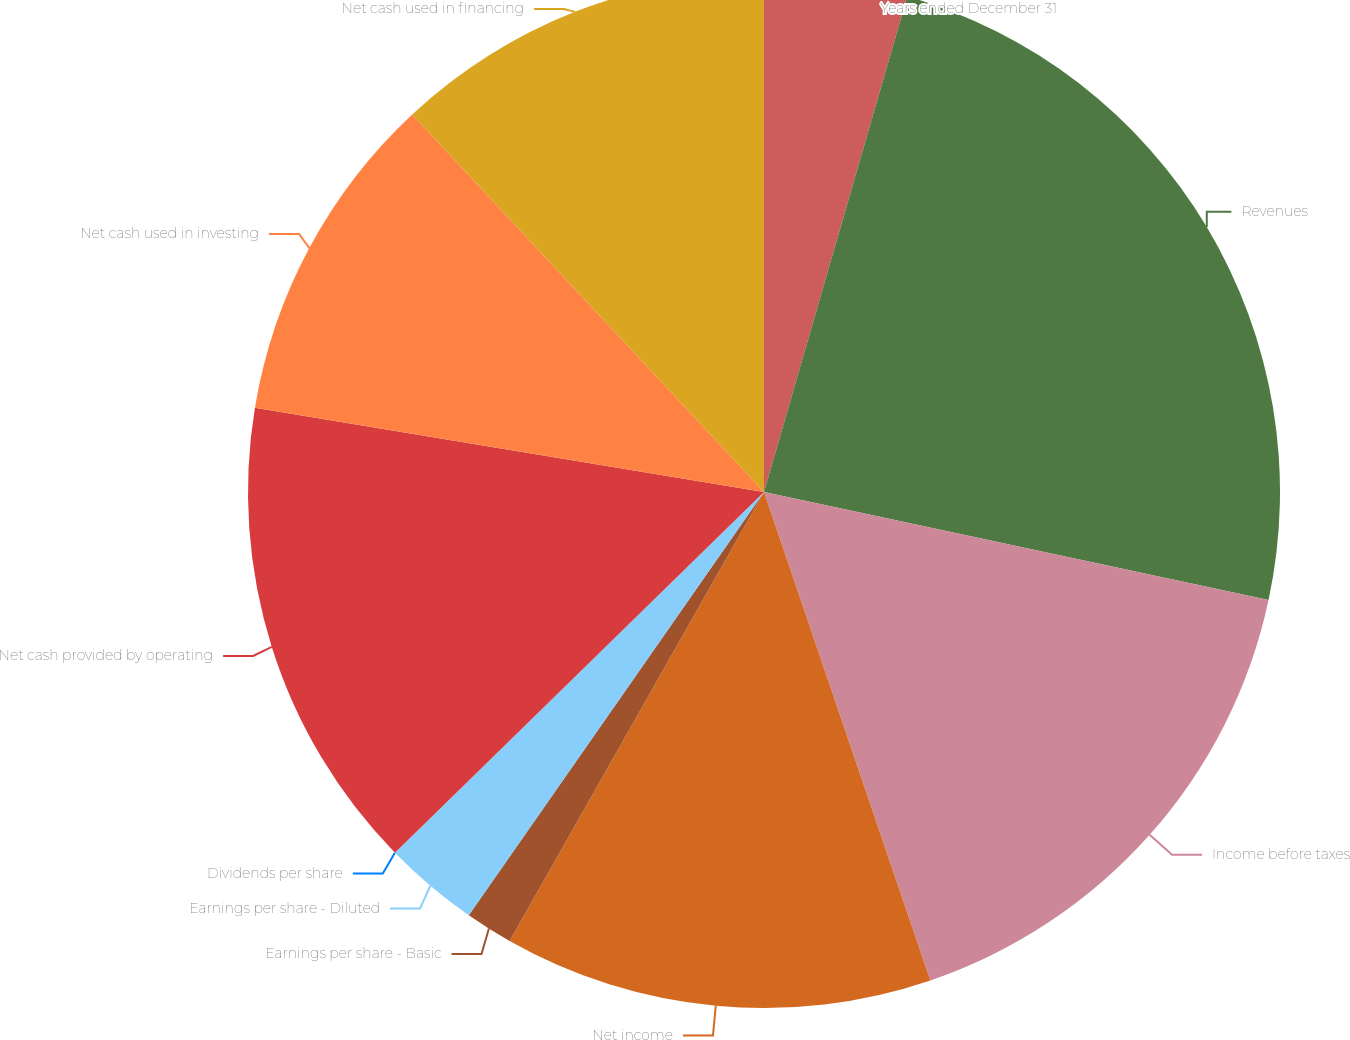Convert chart to OTSL. <chart><loc_0><loc_0><loc_500><loc_500><pie_chart><fcel>Years ended December 31<fcel>Revenues<fcel>Income before taxes<fcel>Net income<fcel>Earnings per share - Basic<fcel>Earnings per share - Diluted<fcel>Dividends per share<fcel>Net cash provided by operating<fcel>Net cash used in investing<fcel>Net cash used in financing<nl><fcel>4.48%<fcel>23.88%<fcel>16.42%<fcel>13.43%<fcel>1.49%<fcel>2.99%<fcel>0.0%<fcel>14.93%<fcel>10.45%<fcel>11.94%<nl></chart> 